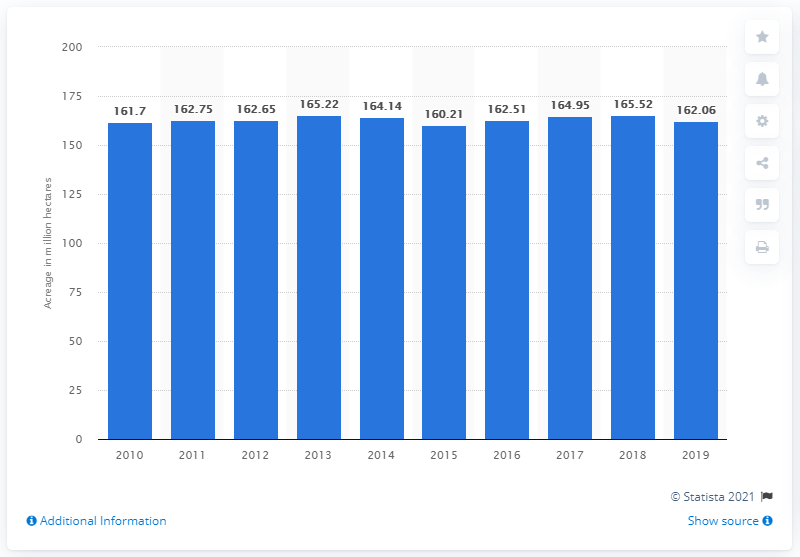Specify some key components in this picture. In crop year 2019, the total amount of rice-cultivated area worldwide was approximately 162.06 million hectares. 